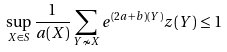<formula> <loc_0><loc_0><loc_500><loc_500>\sup _ { X \in S } \frac { 1 } { a ( X ) } \sum _ { Y \nsim X } e ^ { ( 2 a + b ) ( Y ) } z ( Y ) \leq 1</formula> 